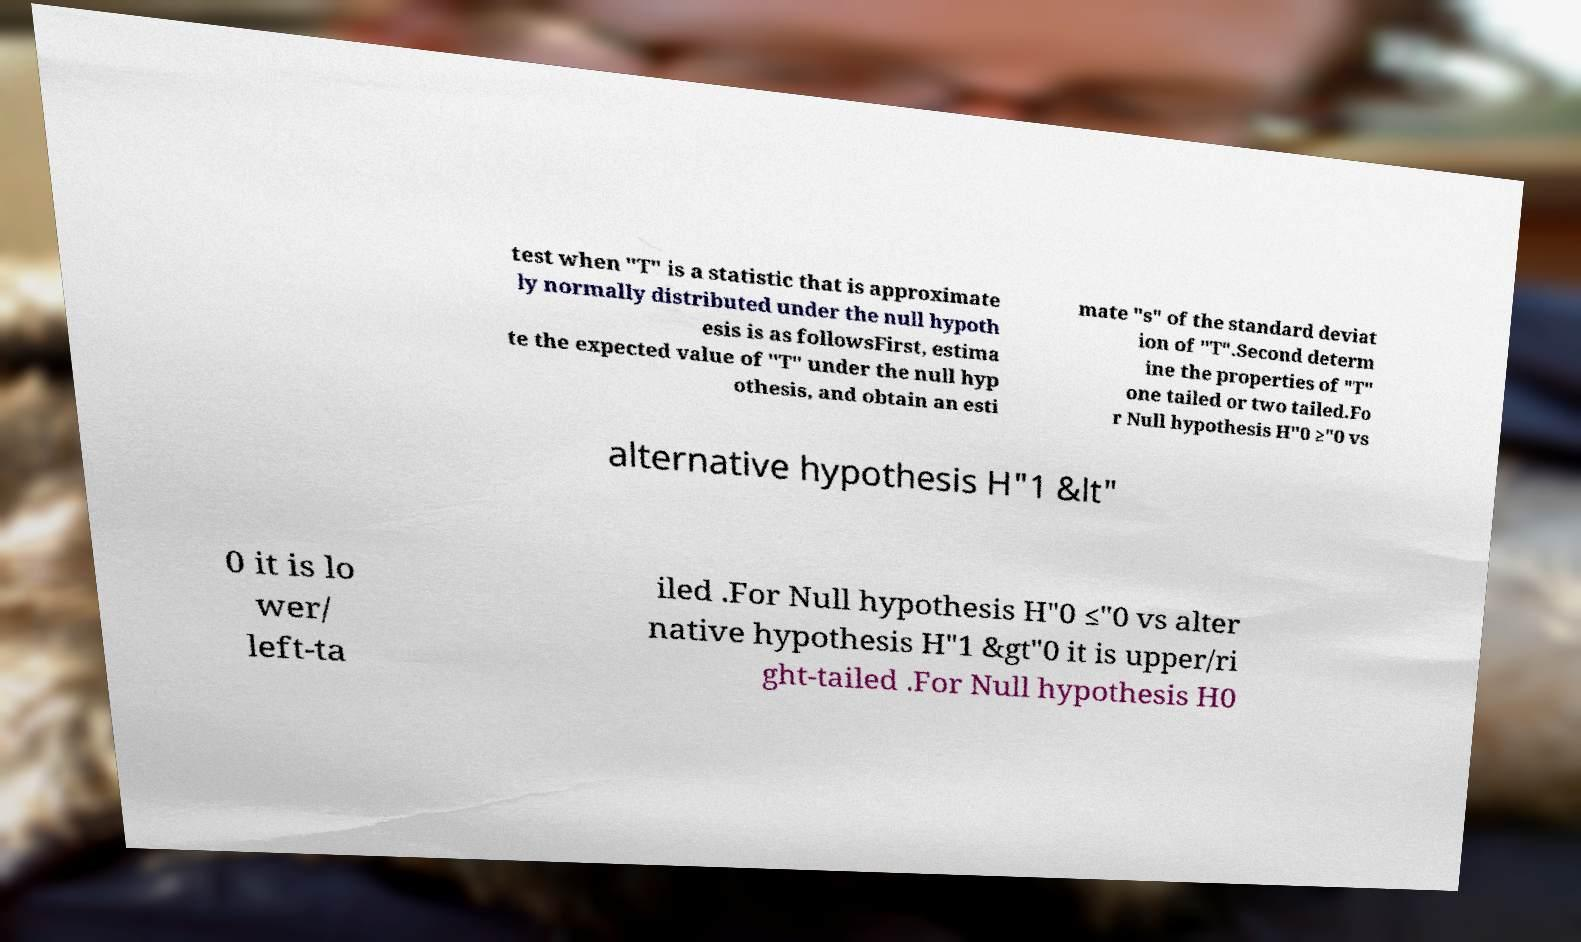Could you assist in decoding the text presented in this image and type it out clearly? test when "T" is a statistic that is approximate ly normally distributed under the null hypoth esis is as followsFirst, estima te the expected value of "T" under the null hyp othesis, and obtain an esti mate "s" of the standard deviat ion of "T".Second determ ine the properties of "T" one tailed or two tailed.Fo r Null hypothesis H"0 ≥"0 vs alternative hypothesis H"1 &lt" 0 it is lo wer/ left-ta iled .For Null hypothesis H"0 ≤"0 vs alter native hypothesis H"1 &gt"0 it is upper/ri ght-tailed .For Null hypothesis H0 